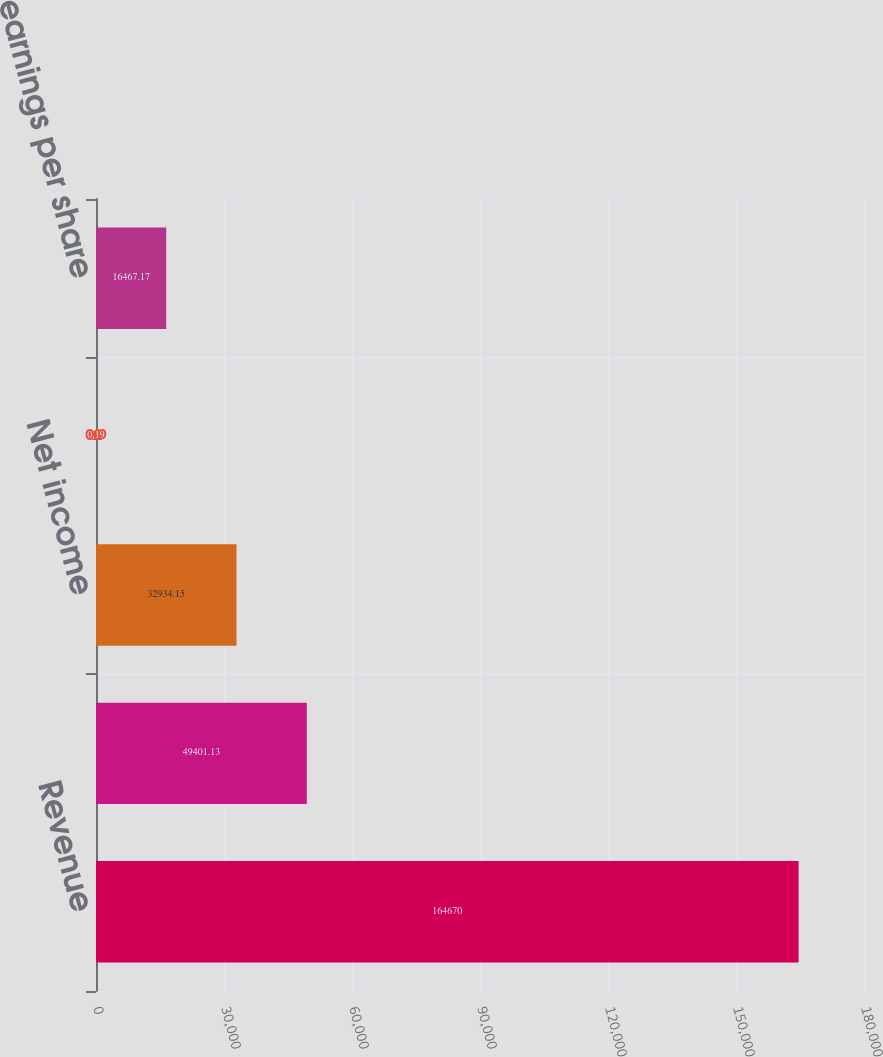Convert chart to OTSL. <chart><loc_0><loc_0><loc_500><loc_500><bar_chart><fcel>Revenue<fcel>Operating income<fcel>Net income<fcel>Basic earnings per share<fcel>Diluted earnings per share<nl><fcel>164670<fcel>49401.1<fcel>32934.2<fcel>0.19<fcel>16467.2<nl></chart> 